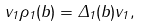<formula> <loc_0><loc_0><loc_500><loc_500>v _ { 1 } \rho _ { 1 } ( b ) = \Delta _ { 1 } ( b ) v _ { 1 } ,</formula> 